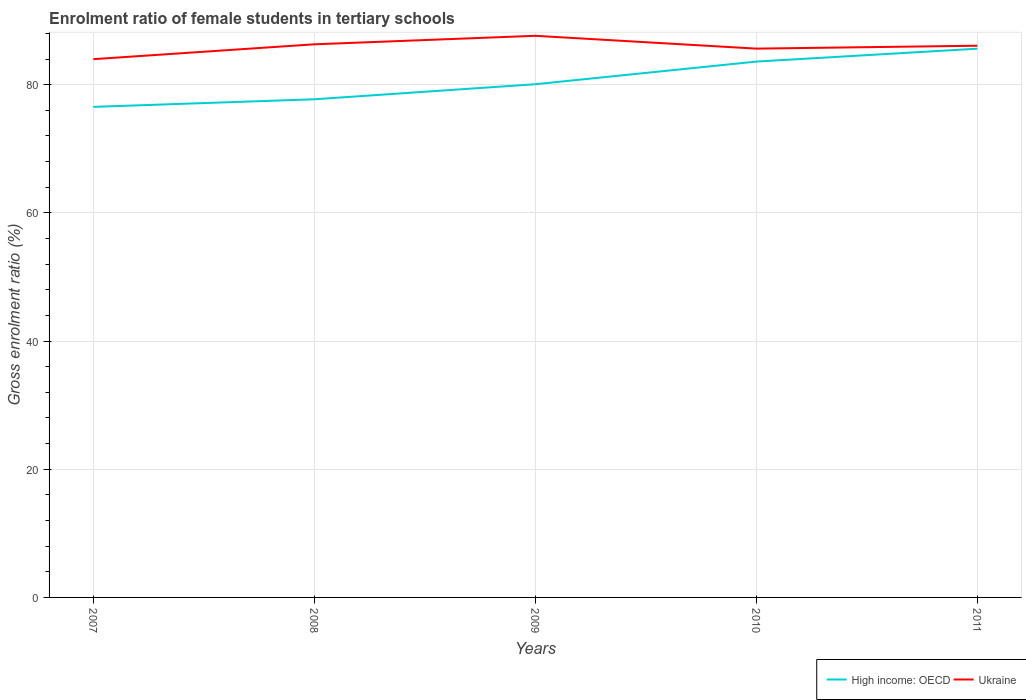Is the number of lines equal to the number of legend labels?
Your answer should be very brief. Yes. Across all years, what is the maximum enrolment ratio of female students in tertiary schools in Ukraine?
Offer a very short reply. 83.98. In which year was the enrolment ratio of female students in tertiary schools in High income: OECD maximum?
Your answer should be compact. 2007. What is the total enrolment ratio of female students in tertiary schools in Ukraine in the graph?
Your response must be concise. 0.67. What is the difference between the highest and the second highest enrolment ratio of female students in tertiary schools in High income: OECD?
Offer a terse response. 9.08. Is the enrolment ratio of female students in tertiary schools in High income: OECD strictly greater than the enrolment ratio of female students in tertiary schools in Ukraine over the years?
Keep it short and to the point. Yes. Does the graph contain any zero values?
Your answer should be very brief. No. Does the graph contain grids?
Ensure brevity in your answer.  Yes. Where does the legend appear in the graph?
Provide a succinct answer. Bottom right. What is the title of the graph?
Your answer should be very brief. Enrolment ratio of female students in tertiary schools. What is the label or title of the Y-axis?
Your answer should be compact. Gross enrolment ratio (%). What is the Gross enrolment ratio (%) in High income: OECD in 2007?
Your answer should be very brief. 76.54. What is the Gross enrolment ratio (%) of Ukraine in 2007?
Make the answer very short. 83.98. What is the Gross enrolment ratio (%) of High income: OECD in 2008?
Your answer should be compact. 77.72. What is the Gross enrolment ratio (%) of Ukraine in 2008?
Keep it short and to the point. 86.3. What is the Gross enrolment ratio (%) in High income: OECD in 2009?
Provide a short and direct response. 80.07. What is the Gross enrolment ratio (%) of Ukraine in 2009?
Keep it short and to the point. 87.63. What is the Gross enrolment ratio (%) in High income: OECD in 2010?
Keep it short and to the point. 83.6. What is the Gross enrolment ratio (%) in Ukraine in 2010?
Your response must be concise. 85.63. What is the Gross enrolment ratio (%) in High income: OECD in 2011?
Give a very brief answer. 85.61. What is the Gross enrolment ratio (%) in Ukraine in 2011?
Keep it short and to the point. 86.08. Across all years, what is the maximum Gross enrolment ratio (%) of High income: OECD?
Make the answer very short. 85.61. Across all years, what is the maximum Gross enrolment ratio (%) in Ukraine?
Give a very brief answer. 87.63. Across all years, what is the minimum Gross enrolment ratio (%) of High income: OECD?
Your answer should be very brief. 76.54. Across all years, what is the minimum Gross enrolment ratio (%) of Ukraine?
Your answer should be compact. 83.98. What is the total Gross enrolment ratio (%) of High income: OECD in the graph?
Make the answer very short. 403.55. What is the total Gross enrolment ratio (%) in Ukraine in the graph?
Your answer should be compact. 429.61. What is the difference between the Gross enrolment ratio (%) in High income: OECD in 2007 and that in 2008?
Offer a very short reply. -1.19. What is the difference between the Gross enrolment ratio (%) in Ukraine in 2007 and that in 2008?
Offer a terse response. -2.32. What is the difference between the Gross enrolment ratio (%) in High income: OECD in 2007 and that in 2009?
Keep it short and to the point. -3.53. What is the difference between the Gross enrolment ratio (%) in Ukraine in 2007 and that in 2009?
Your response must be concise. -3.64. What is the difference between the Gross enrolment ratio (%) in High income: OECD in 2007 and that in 2010?
Your answer should be compact. -7.07. What is the difference between the Gross enrolment ratio (%) in Ukraine in 2007 and that in 2010?
Give a very brief answer. -1.64. What is the difference between the Gross enrolment ratio (%) of High income: OECD in 2007 and that in 2011?
Keep it short and to the point. -9.08. What is the difference between the Gross enrolment ratio (%) in Ukraine in 2007 and that in 2011?
Ensure brevity in your answer.  -2.1. What is the difference between the Gross enrolment ratio (%) in High income: OECD in 2008 and that in 2009?
Offer a terse response. -2.35. What is the difference between the Gross enrolment ratio (%) of Ukraine in 2008 and that in 2009?
Offer a terse response. -1.33. What is the difference between the Gross enrolment ratio (%) of High income: OECD in 2008 and that in 2010?
Keep it short and to the point. -5.88. What is the difference between the Gross enrolment ratio (%) in Ukraine in 2008 and that in 2010?
Your response must be concise. 0.67. What is the difference between the Gross enrolment ratio (%) of High income: OECD in 2008 and that in 2011?
Give a very brief answer. -7.89. What is the difference between the Gross enrolment ratio (%) of Ukraine in 2008 and that in 2011?
Offer a terse response. 0.22. What is the difference between the Gross enrolment ratio (%) in High income: OECD in 2009 and that in 2010?
Provide a succinct answer. -3.53. What is the difference between the Gross enrolment ratio (%) in Ukraine in 2009 and that in 2010?
Provide a succinct answer. 2. What is the difference between the Gross enrolment ratio (%) in High income: OECD in 2009 and that in 2011?
Your answer should be compact. -5.54. What is the difference between the Gross enrolment ratio (%) of Ukraine in 2009 and that in 2011?
Give a very brief answer. 1.55. What is the difference between the Gross enrolment ratio (%) in High income: OECD in 2010 and that in 2011?
Your answer should be compact. -2.01. What is the difference between the Gross enrolment ratio (%) of Ukraine in 2010 and that in 2011?
Your answer should be very brief. -0.45. What is the difference between the Gross enrolment ratio (%) in High income: OECD in 2007 and the Gross enrolment ratio (%) in Ukraine in 2008?
Ensure brevity in your answer.  -9.76. What is the difference between the Gross enrolment ratio (%) of High income: OECD in 2007 and the Gross enrolment ratio (%) of Ukraine in 2009?
Provide a short and direct response. -11.09. What is the difference between the Gross enrolment ratio (%) of High income: OECD in 2007 and the Gross enrolment ratio (%) of Ukraine in 2010?
Your response must be concise. -9.09. What is the difference between the Gross enrolment ratio (%) of High income: OECD in 2007 and the Gross enrolment ratio (%) of Ukraine in 2011?
Make the answer very short. -9.54. What is the difference between the Gross enrolment ratio (%) in High income: OECD in 2008 and the Gross enrolment ratio (%) in Ukraine in 2009?
Your answer should be very brief. -9.9. What is the difference between the Gross enrolment ratio (%) of High income: OECD in 2008 and the Gross enrolment ratio (%) of Ukraine in 2010?
Your response must be concise. -7.9. What is the difference between the Gross enrolment ratio (%) of High income: OECD in 2008 and the Gross enrolment ratio (%) of Ukraine in 2011?
Offer a very short reply. -8.36. What is the difference between the Gross enrolment ratio (%) of High income: OECD in 2009 and the Gross enrolment ratio (%) of Ukraine in 2010?
Provide a succinct answer. -5.55. What is the difference between the Gross enrolment ratio (%) in High income: OECD in 2009 and the Gross enrolment ratio (%) in Ukraine in 2011?
Your response must be concise. -6.01. What is the difference between the Gross enrolment ratio (%) in High income: OECD in 2010 and the Gross enrolment ratio (%) in Ukraine in 2011?
Your response must be concise. -2.47. What is the average Gross enrolment ratio (%) in High income: OECD per year?
Your answer should be very brief. 80.71. What is the average Gross enrolment ratio (%) in Ukraine per year?
Offer a terse response. 85.92. In the year 2007, what is the difference between the Gross enrolment ratio (%) in High income: OECD and Gross enrolment ratio (%) in Ukraine?
Provide a short and direct response. -7.44. In the year 2008, what is the difference between the Gross enrolment ratio (%) in High income: OECD and Gross enrolment ratio (%) in Ukraine?
Provide a succinct answer. -8.58. In the year 2009, what is the difference between the Gross enrolment ratio (%) of High income: OECD and Gross enrolment ratio (%) of Ukraine?
Give a very brief answer. -7.56. In the year 2010, what is the difference between the Gross enrolment ratio (%) of High income: OECD and Gross enrolment ratio (%) of Ukraine?
Provide a succinct answer. -2.02. In the year 2011, what is the difference between the Gross enrolment ratio (%) in High income: OECD and Gross enrolment ratio (%) in Ukraine?
Offer a very short reply. -0.46. What is the ratio of the Gross enrolment ratio (%) of High income: OECD in 2007 to that in 2008?
Your answer should be compact. 0.98. What is the ratio of the Gross enrolment ratio (%) of Ukraine in 2007 to that in 2008?
Provide a short and direct response. 0.97. What is the ratio of the Gross enrolment ratio (%) in High income: OECD in 2007 to that in 2009?
Keep it short and to the point. 0.96. What is the ratio of the Gross enrolment ratio (%) of Ukraine in 2007 to that in 2009?
Give a very brief answer. 0.96. What is the ratio of the Gross enrolment ratio (%) in High income: OECD in 2007 to that in 2010?
Give a very brief answer. 0.92. What is the ratio of the Gross enrolment ratio (%) of Ukraine in 2007 to that in 2010?
Your response must be concise. 0.98. What is the ratio of the Gross enrolment ratio (%) of High income: OECD in 2007 to that in 2011?
Offer a terse response. 0.89. What is the ratio of the Gross enrolment ratio (%) in Ukraine in 2007 to that in 2011?
Keep it short and to the point. 0.98. What is the ratio of the Gross enrolment ratio (%) in High income: OECD in 2008 to that in 2009?
Your answer should be compact. 0.97. What is the ratio of the Gross enrolment ratio (%) in Ukraine in 2008 to that in 2009?
Ensure brevity in your answer.  0.98. What is the ratio of the Gross enrolment ratio (%) of High income: OECD in 2008 to that in 2010?
Your response must be concise. 0.93. What is the ratio of the Gross enrolment ratio (%) in Ukraine in 2008 to that in 2010?
Give a very brief answer. 1.01. What is the ratio of the Gross enrolment ratio (%) in High income: OECD in 2008 to that in 2011?
Offer a terse response. 0.91. What is the ratio of the Gross enrolment ratio (%) of High income: OECD in 2009 to that in 2010?
Provide a short and direct response. 0.96. What is the ratio of the Gross enrolment ratio (%) of Ukraine in 2009 to that in 2010?
Provide a short and direct response. 1.02. What is the ratio of the Gross enrolment ratio (%) of High income: OECD in 2009 to that in 2011?
Your answer should be very brief. 0.94. What is the ratio of the Gross enrolment ratio (%) of Ukraine in 2009 to that in 2011?
Provide a short and direct response. 1.02. What is the ratio of the Gross enrolment ratio (%) of High income: OECD in 2010 to that in 2011?
Ensure brevity in your answer.  0.98. What is the ratio of the Gross enrolment ratio (%) in Ukraine in 2010 to that in 2011?
Provide a succinct answer. 0.99. What is the difference between the highest and the second highest Gross enrolment ratio (%) of High income: OECD?
Ensure brevity in your answer.  2.01. What is the difference between the highest and the second highest Gross enrolment ratio (%) of Ukraine?
Your answer should be very brief. 1.33. What is the difference between the highest and the lowest Gross enrolment ratio (%) in High income: OECD?
Keep it short and to the point. 9.08. What is the difference between the highest and the lowest Gross enrolment ratio (%) of Ukraine?
Your answer should be compact. 3.64. 